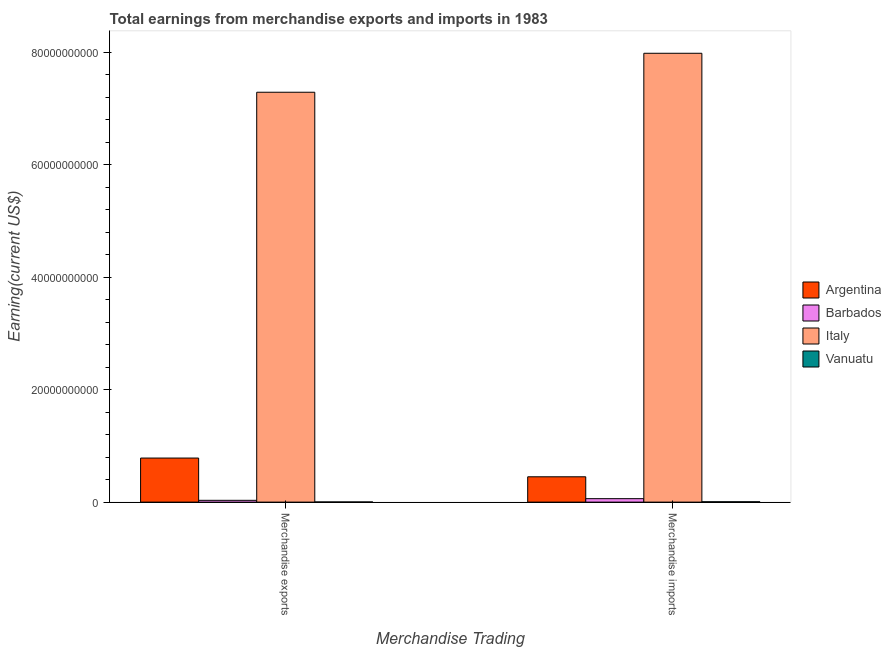How many groups of bars are there?
Offer a terse response. 2. How many bars are there on the 2nd tick from the right?
Your answer should be compact. 4. What is the label of the 2nd group of bars from the left?
Make the answer very short. Merchandise imports. What is the earnings from merchandise exports in Vanuatu?
Give a very brief answer. 2.90e+07. Across all countries, what is the maximum earnings from merchandise imports?
Give a very brief answer. 7.98e+1. Across all countries, what is the minimum earnings from merchandise exports?
Offer a terse response. 2.90e+07. In which country was the earnings from merchandise imports minimum?
Make the answer very short. Vanuatu. What is the total earnings from merchandise imports in the graph?
Offer a terse response. 8.50e+1. What is the difference between the earnings from merchandise exports in Argentina and that in Barbados?
Keep it short and to the point. 7.52e+09. What is the difference between the earnings from merchandise imports in Barbados and the earnings from merchandise exports in Argentina?
Provide a short and direct response. -7.22e+09. What is the average earnings from merchandise exports per country?
Keep it short and to the point. 2.03e+1. What is the difference between the earnings from merchandise exports and earnings from merchandise imports in Vanuatu?
Provide a short and direct response. -3.50e+07. In how many countries, is the earnings from merchandise exports greater than 16000000000 US$?
Your answer should be very brief. 1. What is the ratio of the earnings from merchandise imports in Vanuatu to that in Italy?
Offer a terse response. 0. Is the earnings from merchandise imports in Argentina less than that in Vanuatu?
Keep it short and to the point. No. In how many countries, is the earnings from merchandise exports greater than the average earnings from merchandise exports taken over all countries?
Provide a succinct answer. 1. What does the 4th bar from the right in Merchandise imports represents?
Give a very brief answer. Argentina. Are all the bars in the graph horizontal?
Your response must be concise. No. Are the values on the major ticks of Y-axis written in scientific E-notation?
Offer a terse response. No. Does the graph contain any zero values?
Offer a terse response. No. Does the graph contain grids?
Your response must be concise. No. Where does the legend appear in the graph?
Offer a very short reply. Center right. How many legend labels are there?
Your answer should be compact. 4. How are the legend labels stacked?
Give a very brief answer. Vertical. What is the title of the graph?
Make the answer very short. Total earnings from merchandise exports and imports in 1983. What is the label or title of the X-axis?
Your answer should be compact. Merchandise Trading. What is the label or title of the Y-axis?
Make the answer very short. Earning(current US$). What is the Earning(current US$) of Argentina in Merchandise exports?
Ensure brevity in your answer.  7.84e+09. What is the Earning(current US$) in Barbados in Merchandise exports?
Your response must be concise. 3.21e+08. What is the Earning(current US$) of Italy in Merchandise exports?
Provide a short and direct response. 7.29e+1. What is the Earning(current US$) in Vanuatu in Merchandise exports?
Ensure brevity in your answer.  2.90e+07. What is the Earning(current US$) of Argentina in Merchandise imports?
Give a very brief answer. 4.50e+09. What is the Earning(current US$) in Barbados in Merchandise imports?
Offer a terse response. 6.16e+08. What is the Earning(current US$) of Italy in Merchandise imports?
Provide a succinct answer. 7.98e+1. What is the Earning(current US$) in Vanuatu in Merchandise imports?
Make the answer very short. 6.40e+07. Across all Merchandise Trading, what is the maximum Earning(current US$) of Argentina?
Your answer should be compact. 7.84e+09. Across all Merchandise Trading, what is the maximum Earning(current US$) in Barbados?
Give a very brief answer. 6.16e+08. Across all Merchandise Trading, what is the maximum Earning(current US$) in Italy?
Your answer should be very brief. 7.98e+1. Across all Merchandise Trading, what is the maximum Earning(current US$) in Vanuatu?
Your response must be concise. 6.40e+07. Across all Merchandise Trading, what is the minimum Earning(current US$) of Argentina?
Give a very brief answer. 4.50e+09. Across all Merchandise Trading, what is the minimum Earning(current US$) of Barbados?
Offer a very short reply. 3.21e+08. Across all Merchandise Trading, what is the minimum Earning(current US$) of Italy?
Your answer should be very brief. 7.29e+1. Across all Merchandise Trading, what is the minimum Earning(current US$) of Vanuatu?
Provide a succinct answer. 2.90e+07. What is the total Earning(current US$) of Argentina in the graph?
Ensure brevity in your answer.  1.23e+1. What is the total Earning(current US$) in Barbados in the graph?
Your response must be concise. 9.37e+08. What is the total Earning(current US$) of Italy in the graph?
Ensure brevity in your answer.  1.53e+11. What is the total Earning(current US$) of Vanuatu in the graph?
Provide a short and direct response. 9.30e+07. What is the difference between the Earning(current US$) of Argentina in Merchandise exports and that in Merchandise imports?
Ensure brevity in your answer.  3.33e+09. What is the difference between the Earning(current US$) in Barbados in Merchandise exports and that in Merchandise imports?
Offer a very short reply. -2.95e+08. What is the difference between the Earning(current US$) in Italy in Merchandise exports and that in Merchandise imports?
Provide a succinct answer. -6.93e+09. What is the difference between the Earning(current US$) in Vanuatu in Merchandise exports and that in Merchandise imports?
Give a very brief answer. -3.50e+07. What is the difference between the Earning(current US$) in Argentina in Merchandise exports and the Earning(current US$) in Barbados in Merchandise imports?
Your response must be concise. 7.22e+09. What is the difference between the Earning(current US$) in Argentina in Merchandise exports and the Earning(current US$) in Italy in Merchandise imports?
Give a very brief answer. -7.20e+1. What is the difference between the Earning(current US$) in Argentina in Merchandise exports and the Earning(current US$) in Vanuatu in Merchandise imports?
Provide a short and direct response. 7.77e+09. What is the difference between the Earning(current US$) of Barbados in Merchandise exports and the Earning(current US$) of Italy in Merchandise imports?
Provide a succinct answer. -7.95e+1. What is the difference between the Earning(current US$) of Barbados in Merchandise exports and the Earning(current US$) of Vanuatu in Merchandise imports?
Offer a very short reply. 2.57e+08. What is the difference between the Earning(current US$) in Italy in Merchandise exports and the Earning(current US$) in Vanuatu in Merchandise imports?
Make the answer very short. 7.28e+1. What is the average Earning(current US$) of Argentina per Merchandise Trading?
Your response must be concise. 6.17e+09. What is the average Earning(current US$) of Barbados per Merchandise Trading?
Your response must be concise. 4.68e+08. What is the average Earning(current US$) in Italy per Merchandise Trading?
Your answer should be very brief. 7.63e+1. What is the average Earning(current US$) in Vanuatu per Merchandise Trading?
Offer a terse response. 4.65e+07. What is the difference between the Earning(current US$) in Argentina and Earning(current US$) in Barbados in Merchandise exports?
Give a very brief answer. 7.52e+09. What is the difference between the Earning(current US$) in Argentina and Earning(current US$) in Italy in Merchandise exports?
Ensure brevity in your answer.  -6.50e+1. What is the difference between the Earning(current US$) of Argentina and Earning(current US$) of Vanuatu in Merchandise exports?
Your response must be concise. 7.81e+09. What is the difference between the Earning(current US$) of Barbados and Earning(current US$) of Italy in Merchandise exports?
Your answer should be compact. -7.26e+1. What is the difference between the Earning(current US$) in Barbados and Earning(current US$) in Vanuatu in Merchandise exports?
Your answer should be very brief. 2.92e+08. What is the difference between the Earning(current US$) of Italy and Earning(current US$) of Vanuatu in Merchandise exports?
Offer a terse response. 7.28e+1. What is the difference between the Earning(current US$) in Argentina and Earning(current US$) in Barbados in Merchandise imports?
Offer a very short reply. 3.89e+09. What is the difference between the Earning(current US$) in Argentina and Earning(current US$) in Italy in Merchandise imports?
Offer a terse response. -7.53e+1. What is the difference between the Earning(current US$) in Argentina and Earning(current US$) in Vanuatu in Merchandise imports?
Ensure brevity in your answer.  4.44e+09. What is the difference between the Earning(current US$) in Barbados and Earning(current US$) in Italy in Merchandise imports?
Provide a succinct answer. -7.92e+1. What is the difference between the Earning(current US$) of Barbados and Earning(current US$) of Vanuatu in Merchandise imports?
Your answer should be compact. 5.52e+08. What is the difference between the Earning(current US$) of Italy and Earning(current US$) of Vanuatu in Merchandise imports?
Your answer should be compact. 7.97e+1. What is the ratio of the Earning(current US$) of Argentina in Merchandise exports to that in Merchandise imports?
Your answer should be very brief. 1.74. What is the ratio of the Earning(current US$) of Barbados in Merchandise exports to that in Merchandise imports?
Provide a succinct answer. 0.52. What is the ratio of the Earning(current US$) of Italy in Merchandise exports to that in Merchandise imports?
Offer a terse response. 0.91. What is the ratio of the Earning(current US$) of Vanuatu in Merchandise exports to that in Merchandise imports?
Your answer should be very brief. 0.45. What is the difference between the highest and the second highest Earning(current US$) in Argentina?
Your answer should be very brief. 3.33e+09. What is the difference between the highest and the second highest Earning(current US$) in Barbados?
Make the answer very short. 2.95e+08. What is the difference between the highest and the second highest Earning(current US$) of Italy?
Offer a very short reply. 6.93e+09. What is the difference between the highest and the second highest Earning(current US$) in Vanuatu?
Offer a terse response. 3.50e+07. What is the difference between the highest and the lowest Earning(current US$) of Argentina?
Ensure brevity in your answer.  3.33e+09. What is the difference between the highest and the lowest Earning(current US$) of Barbados?
Make the answer very short. 2.95e+08. What is the difference between the highest and the lowest Earning(current US$) in Italy?
Make the answer very short. 6.93e+09. What is the difference between the highest and the lowest Earning(current US$) in Vanuatu?
Your answer should be compact. 3.50e+07. 